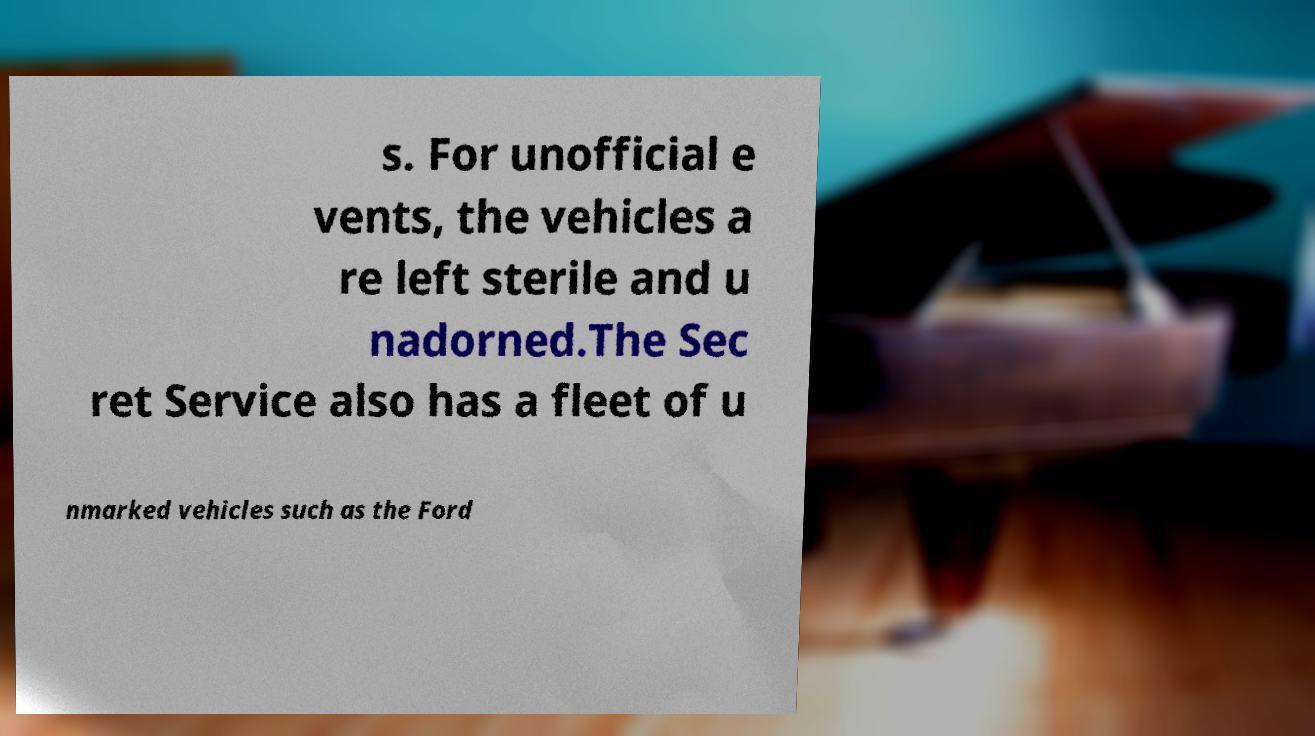Could you assist in decoding the text presented in this image and type it out clearly? s. For unofficial e vents, the vehicles a re left sterile and u nadorned.The Sec ret Service also has a fleet of u nmarked vehicles such as the Ford 